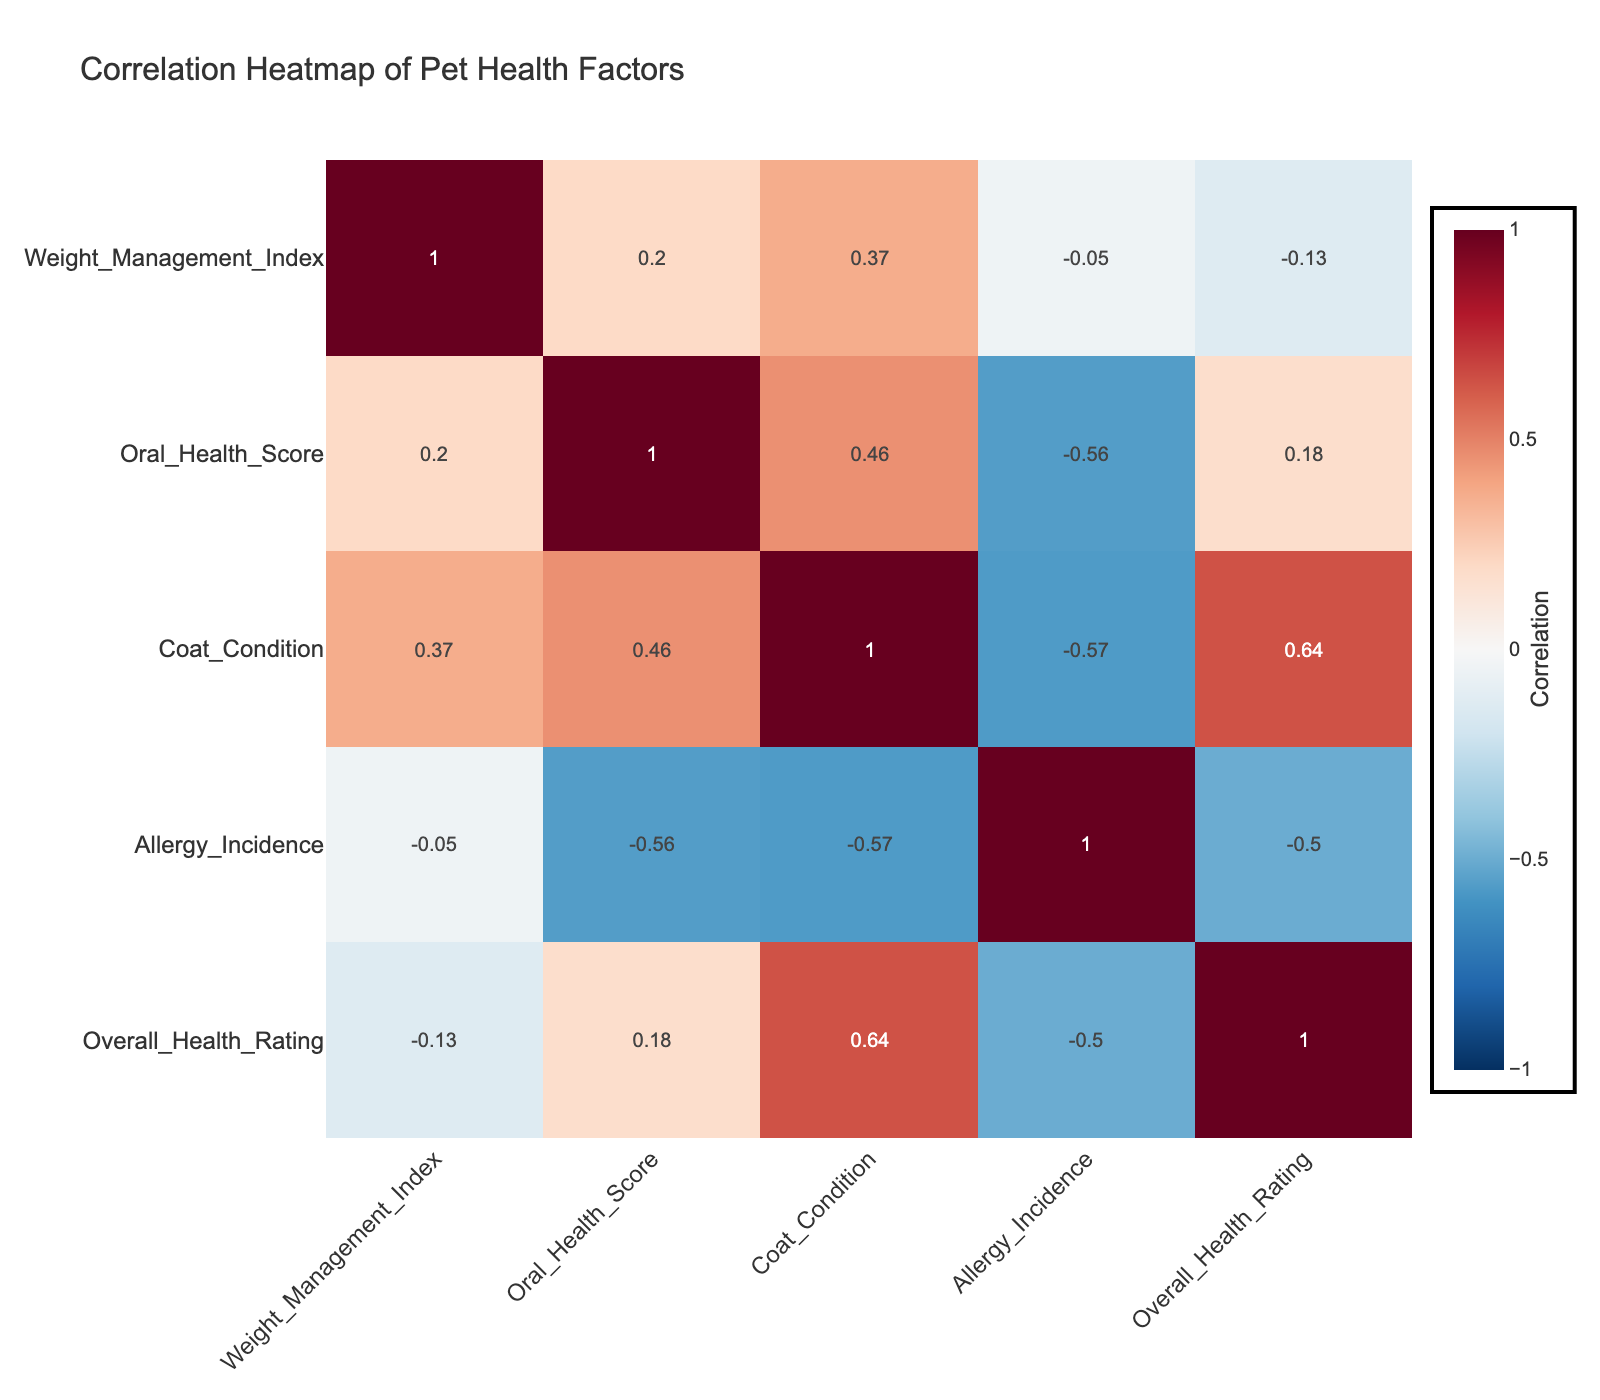What is the correlation between Weight Management Index and Overall Health Rating? The table shows a correlation value of -0.22 between Weight Management Index and Overall Health Rating, indicating a slight inverse relationship where higher weight management scores might relate to lower overall health ratings.
Answer: -0.22 Which nutrition type has the highest Oral Health Score on average? By looking at the Oral Health Scores for each Nutrition Type, Raw Diet has the highest average score calculated as (6 + 7 + 9) / 3 = 7.33, consistently scoring well across its entries.
Answer: Raw Diet Is there a positive correlation between Activity Level and Overall Health Rating? The table presents a correlation coefficient of 0.12, suggesting a very weak positive relationship between Activity Level and Overall Health Rating, though closer inspection of other scores can provide more context.
Answer: No What is the average Coat Condition score for pets on a Wet Food diet? The Wet Food entries have Coat Condition scores of 9 for the Golden Retriever and 7 for the Boxer. The average is calculated as (9 + 7) / 2 = 8.
Answer: 8 Does a higher Allergy Incidence score correlate with a lower Overall Health Rating? Yes, observing the correlation gives -0.75 suggesting that as Allergy Incidence increases, Overall Health Rating tends to decrease significantly, indicating a strong negative relationship.
Answer: Yes What is the difference in average Weight Management Index between Grain-Free and Dry Kibble diets? Grain-Free scores are 4.5 and 4.1, while Dry Kibble scores are 3.5 and 4.2. Their averages are (4.5 + 4.1) / 2 = 4.3 and (3.5 + 4.2) / 2 = 3.85. The difference is 4.3 - 3.85 = 0.45.
Answer: 0.45 What nutritional type has the lowest Average Allergy Incidence score? The Allergy Incidence scores for each nutritional type are 2 for both Dry Kibble and Homemade, making them the lowest.
Answer: Dry Kibble and Homemade Is the Activity Level a better predictor of Oral Health Score compared to Weight Management Index? By comparing the correlation values of 0.12 for Activity Level and 0.21 for Weight Management Index, we conclude that Weight Management Index shows a moderately stronger relationship with Oral Health Scores, suggesting it's a better predictor.
Answer: Yes What is the overall trend when comparing activity levels across different pets against their overall health ratings? Evaluating the information reveals that pets with high activity levels generally show better overall health ratings compared to low activity pets, showcasing an upward trend in health outcomes related to increased physical activity.
Answer: Positive Trend 